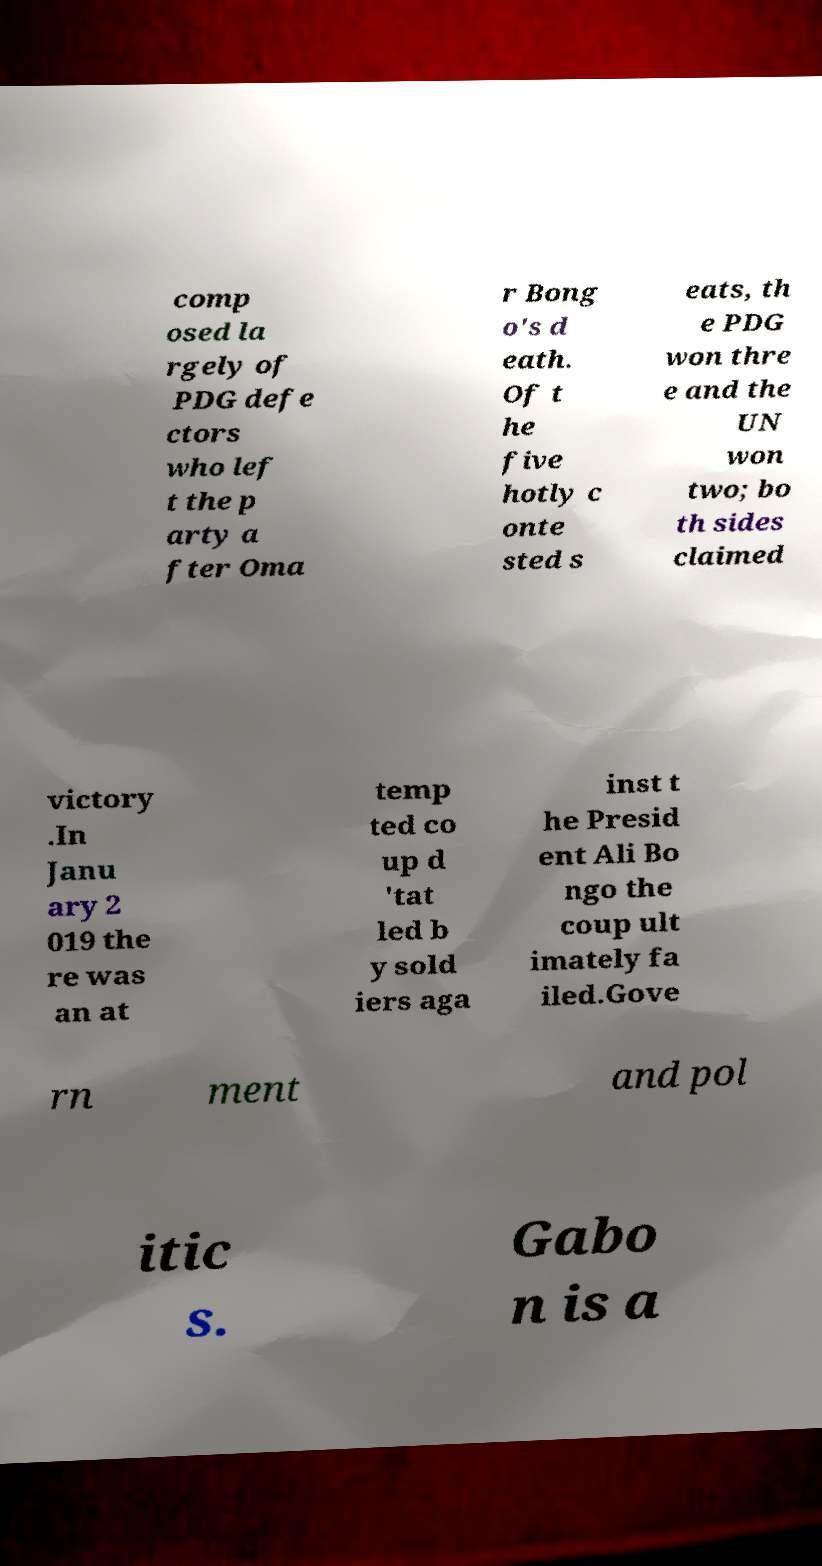Can you read and provide the text displayed in the image?This photo seems to have some interesting text. Can you extract and type it out for me? comp osed la rgely of PDG defe ctors who lef t the p arty a fter Oma r Bong o's d eath. Of t he five hotly c onte sted s eats, th e PDG won thre e and the UN won two; bo th sides claimed victory .In Janu ary 2 019 the re was an at temp ted co up d 'tat led b y sold iers aga inst t he Presid ent Ali Bo ngo the coup ult imately fa iled.Gove rn ment and pol itic s. Gabo n is a 